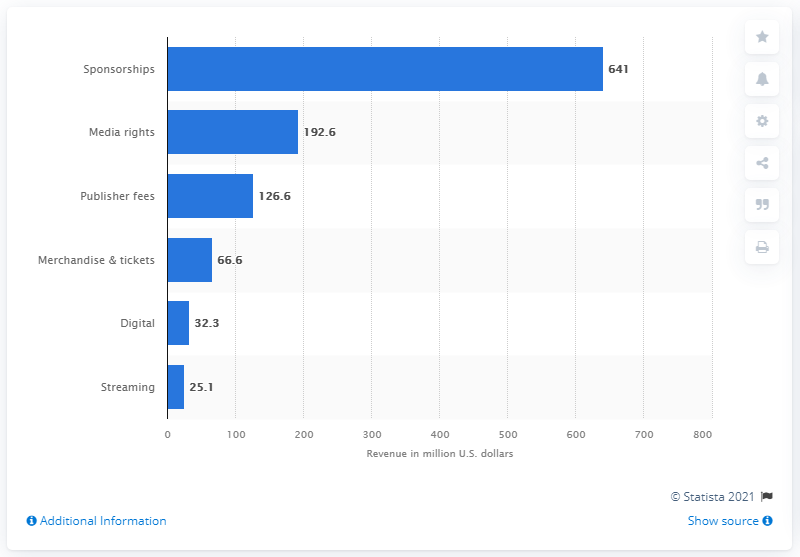Point out several critical features in this image. In 2021, the merchandise and tickets segment of the global eSports market was estimated to generate approximately $66.6 million in revenue. 